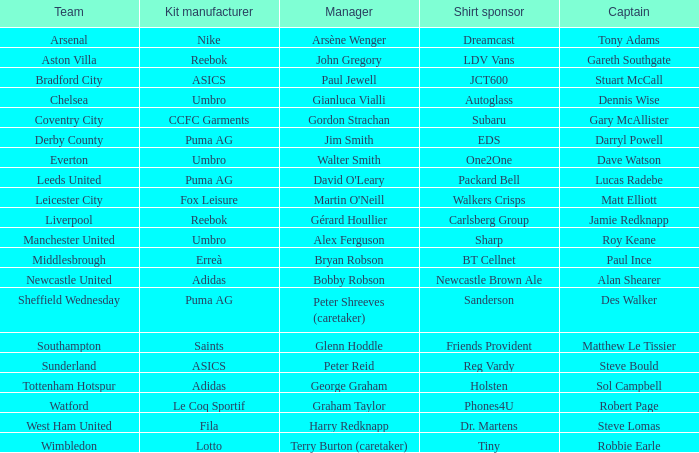Which Kit manufacturer sponsers Arsenal? Nike. Parse the table in full. {'header': ['Team', 'Kit manufacturer', 'Manager', 'Shirt sponsor', 'Captain'], 'rows': [['Arsenal', 'Nike', 'Arsène Wenger', 'Dreamcast', 'Tony Adams'], ['Aston Villa', 'Reebok', 'John Gregory', 'LDV Vans', 'Gareth Southgate'], ['Bradford City', 'ASICS', 'Paul Jewell', 'JCT600', 'Stuart McCall'], ['Chelsea', 'Umbro', 'Gianluca Vialli', 'Autoglass', 'Dennis Wise'], ['Coventry City', 'CCFC Garments', 'Gordon Strachan', 'Subaru', 'Gary McAllister'], ['Derby County', 'Puma AG', 'Jim Smith', 'EDS', 'Darryl Powell'], ['Everton', 'Umbro', 'Walter Smith', 'One2One', 'Dave Watson'], ['Leeds United', 'Puma AG', "David O'Leary", 'Packard Bell', 'Lucas Radebe'], ['Leicester City', 'Fox Leisure', "Martin O'Neill", 'Walkers Crisps', 'Matt Elliott'], ['Liverpool', 'Reebok', 'Gérard Houllier', 'Carlsberg Group', 'Jamie Redknapp'], ['Manchester United', 'Umbro', 'Alex Ferguson', 'Sharp', 'Roy Keane'], ['Middlesbrough', 'Erreà', 'Bryan Robson', 'BT Cellnet', 'Paul Ince'], ['Newcastle United', 'Adidas', 'Bobby Robson', 'Newcastle Brown Ale', 'Alan Shearer'], ['Sheffield Wednesday', 'Puma AG', 'Peter Shreeves (caretaker)', 'Sanderson', 'Des Walker'], ['Southampton', 'Saints', 'Glenn Hoddle', 'Friends Provident', 'Matthew Le Tissier'], ['Sunderland', 'ASICS', 'Peter Reid', 'Reg Vardy', 'Steve Bould'], ['Tottenham Hotspur', 'Adidas', 'George Graham', 'Holsten', 'Sol Campbell'], ['Watford', 'Le Coq Sportif', 'Graham Taylor', 'Phones4U', 'Robert Page'], ['West Ham United', 'Fila', 'Harry Redknapp', 'Dr. Martens', 'Steve Lomas'], ['Wimbledon', 'Lotto', 'Terry Burton (caretaker)', 'Tiny', 'Robbie Earle']]} 